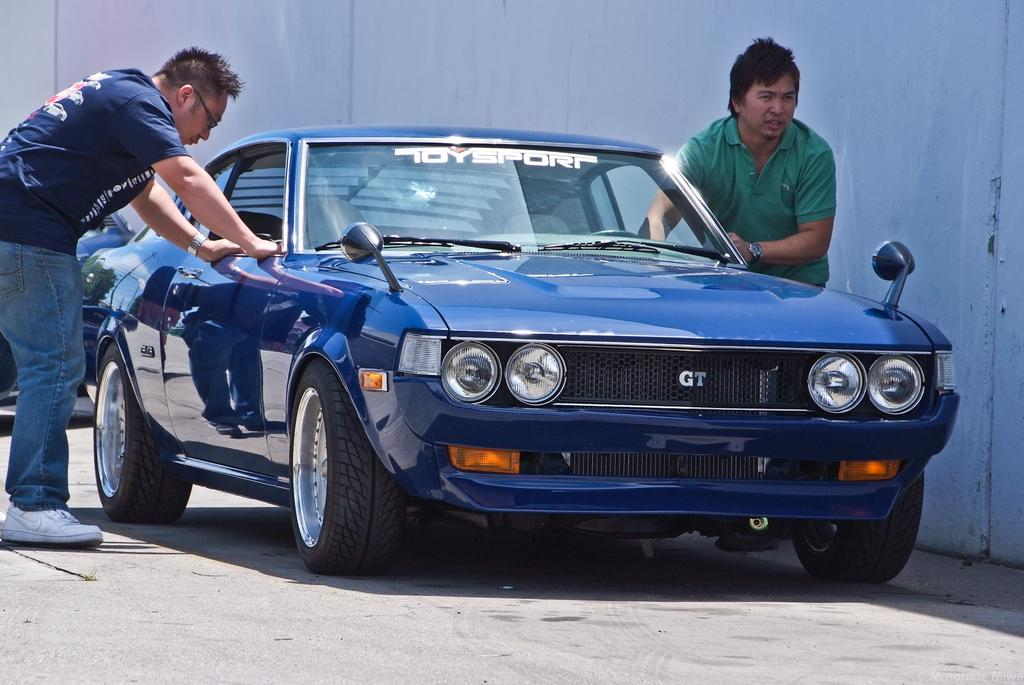What is the main subject of the image? The main subject of the image is a car. Are there any people in the image? Yes, there are two persons beside the car. What else can be seen in the image? There is a wall in the image. What type of crack is visible on the car's windshield in the image? There is no crack visible on the car's windshield in the image. What guidebook is the person holding while standing beside the car in the image? There is no guidebook visible in the image. 